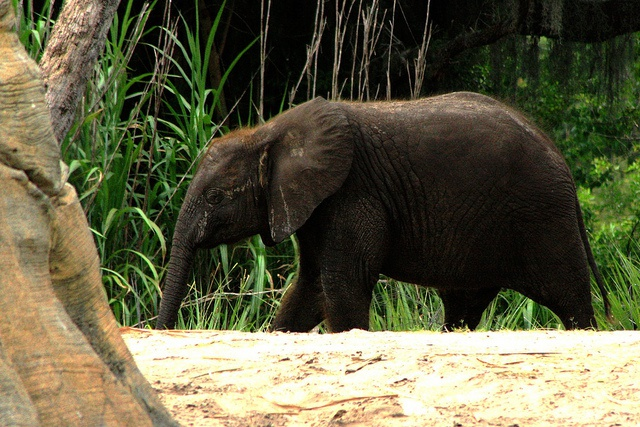Describe the objects in this image and their specific colors. I can see a elephant in tan, black, darkgreen, and gray tones in this image. 